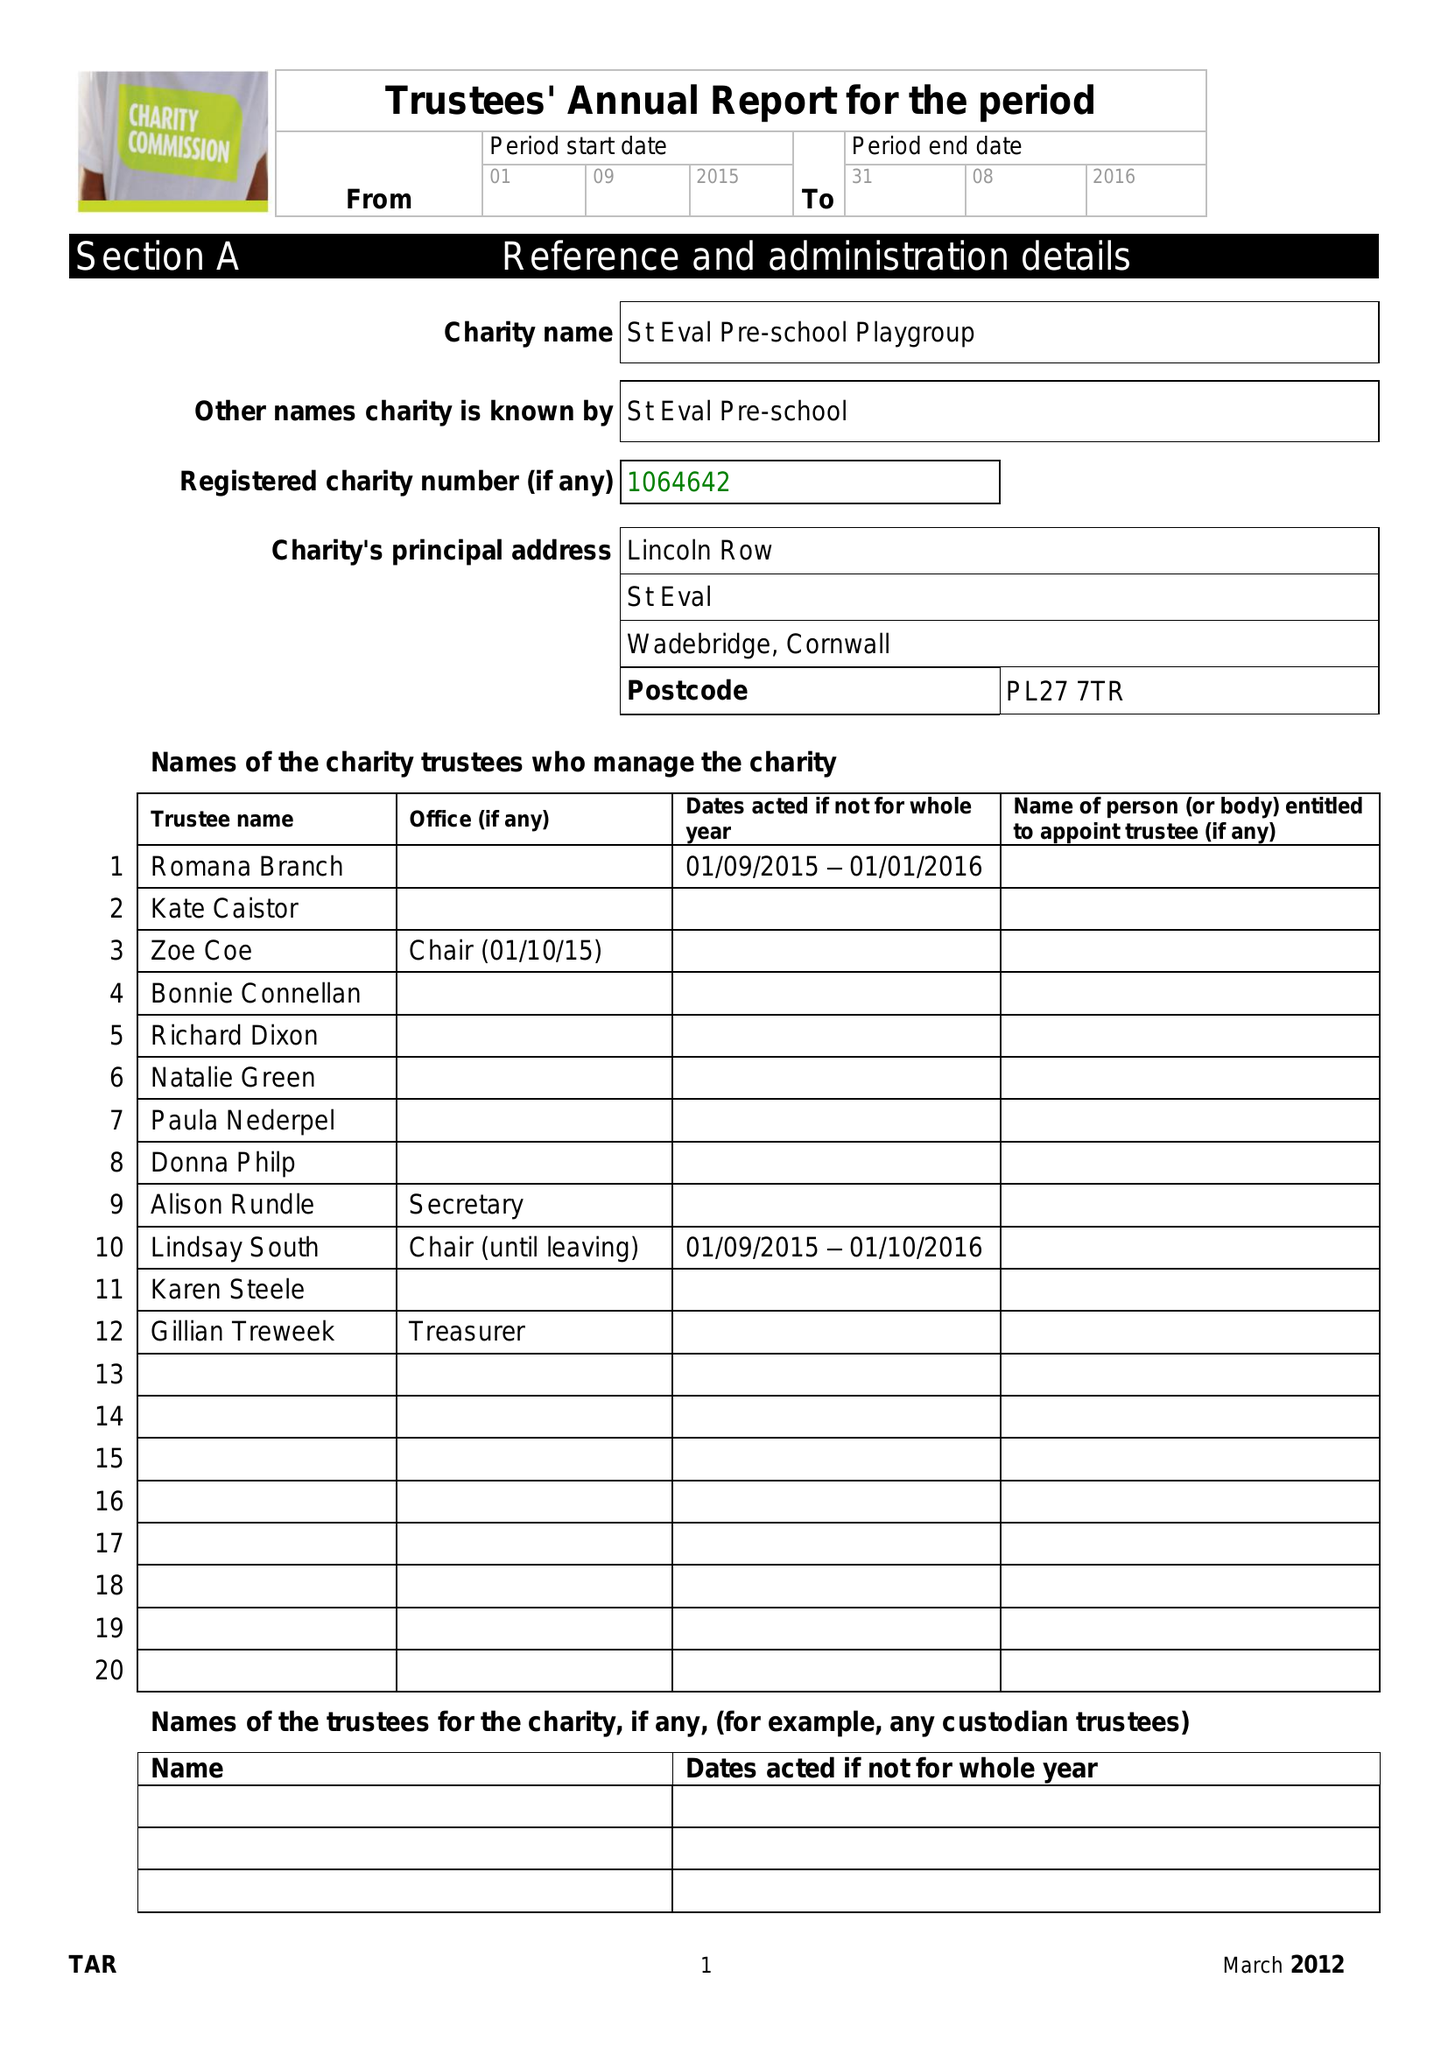What is the value for the income_annually_in_british_pounds?
Answer the question using a single word or phrase. 121433.03 